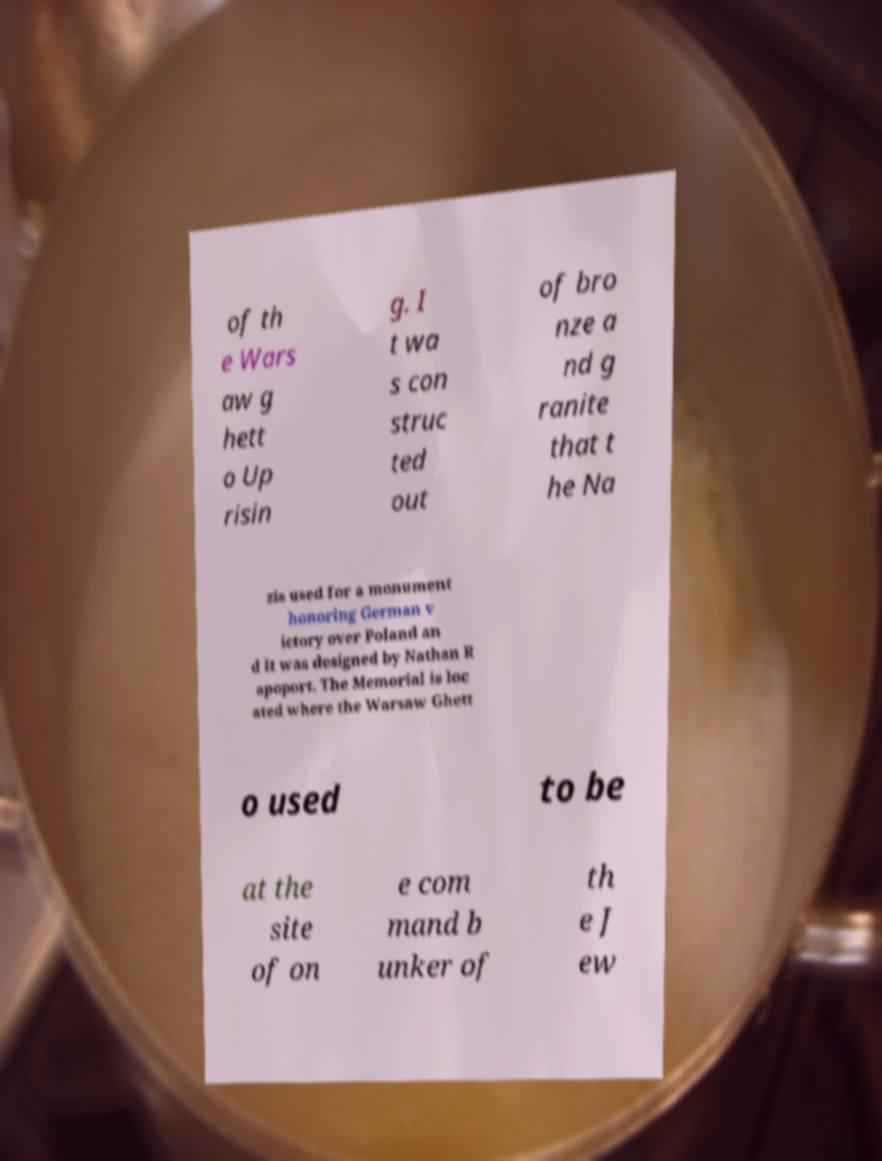Please read and relay the text visible in this image. What does it say? of th e Wars aw g hett o Up risin g. I t wa s con struc ted out of bro nze a nd g ranite that t he Na zis used for a monument honoring German v ictory over Poland an d it was designed by Nathan R apoport. The Memorial is loc ated where the Warsaw Ghett o used to be at the site of on e com mand b unker of th e J ew 